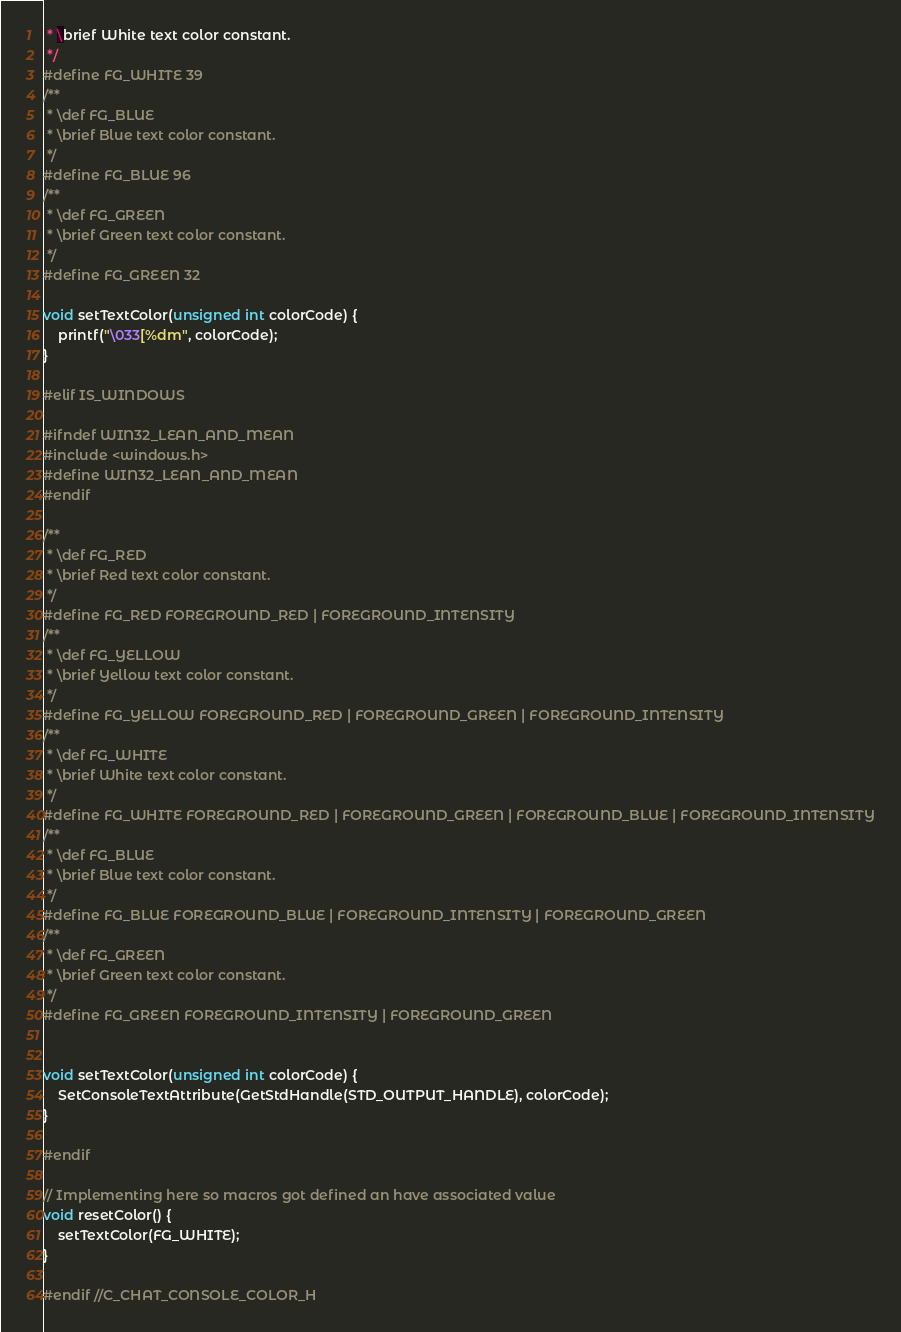Convert code to text. <code><loc_0><loc_0><loc_500><loc_500><_C_> * \brief White text color constant.
 */
#define FG_WHITE 39
/**
 * \def FG_BLUE
 * \brief Blue text color constant.
 */
#define FG_BLUE 96
/**
 * \def FG_GREEN
 * \brief Green text color constant.
 */
#define FG_GREEN 32

void setTextColor(unsigned int colorCode) {
    printf("\033[%dm", colorCode);
}

#elif IS_WINDOWS

#ifndef WIN32_LEAN_AND_MEAN
#include <windows.h>
#define WIN32_LEAN_AND_MEAN
#endif

/**
 * \def FG_RED
 * \brief Red text color constant.
 */
#define FG_RED FOREGROUND_RED | FOREGROUND_INTENSITY
/**
 * \def FG_YELLOW
 * \brief Yellow text color constant.
 */
#define FG_YELLOW FOREGROUND_RED | FOREGROUND_GREEN | FOREGROUND_INTENSITY
/**
 * \def FG_WHITE
 * \brief White text color constant.
 */
#define FG_WHITE FOREGROUND_RED | FOREGROUND_GREEN | FOREGROUND_BLUE | FOREGROUND_INTENSITY
/**
 * \def FG_BLUE
 * \brief Blue text color constant.
 */
#define FG_BLUE FOREGROUND_BLUE | FOREGROUND_INTENSITY | FOREGROUND_GREEN
/**
 * \def FG_GREEN
 * \brief Green text color constant.
 */
#define FG_GREEN FOREGROUND_INTENSITY | FOREGROUND_GREEN


void setTextColor(unsigned int colorCode) {
    SetConsoleTextAttribute(GetStdHandle(STD_OUTPUT_HANDLE), colorCode);
}

#endif

// Implementing here so macros got defined an have associated value
void resetColor() {
    setTextColor(FG_WHITE);
}

#endif //C_CHAT_CONSOLE_COLOR_H
</code> 